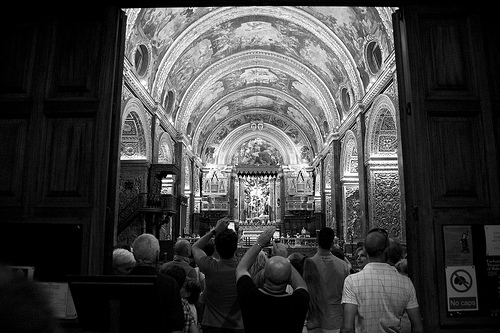Are there men to the left of the picture? Yes, there are several men on the left side of the picture, admiring the architecture. 